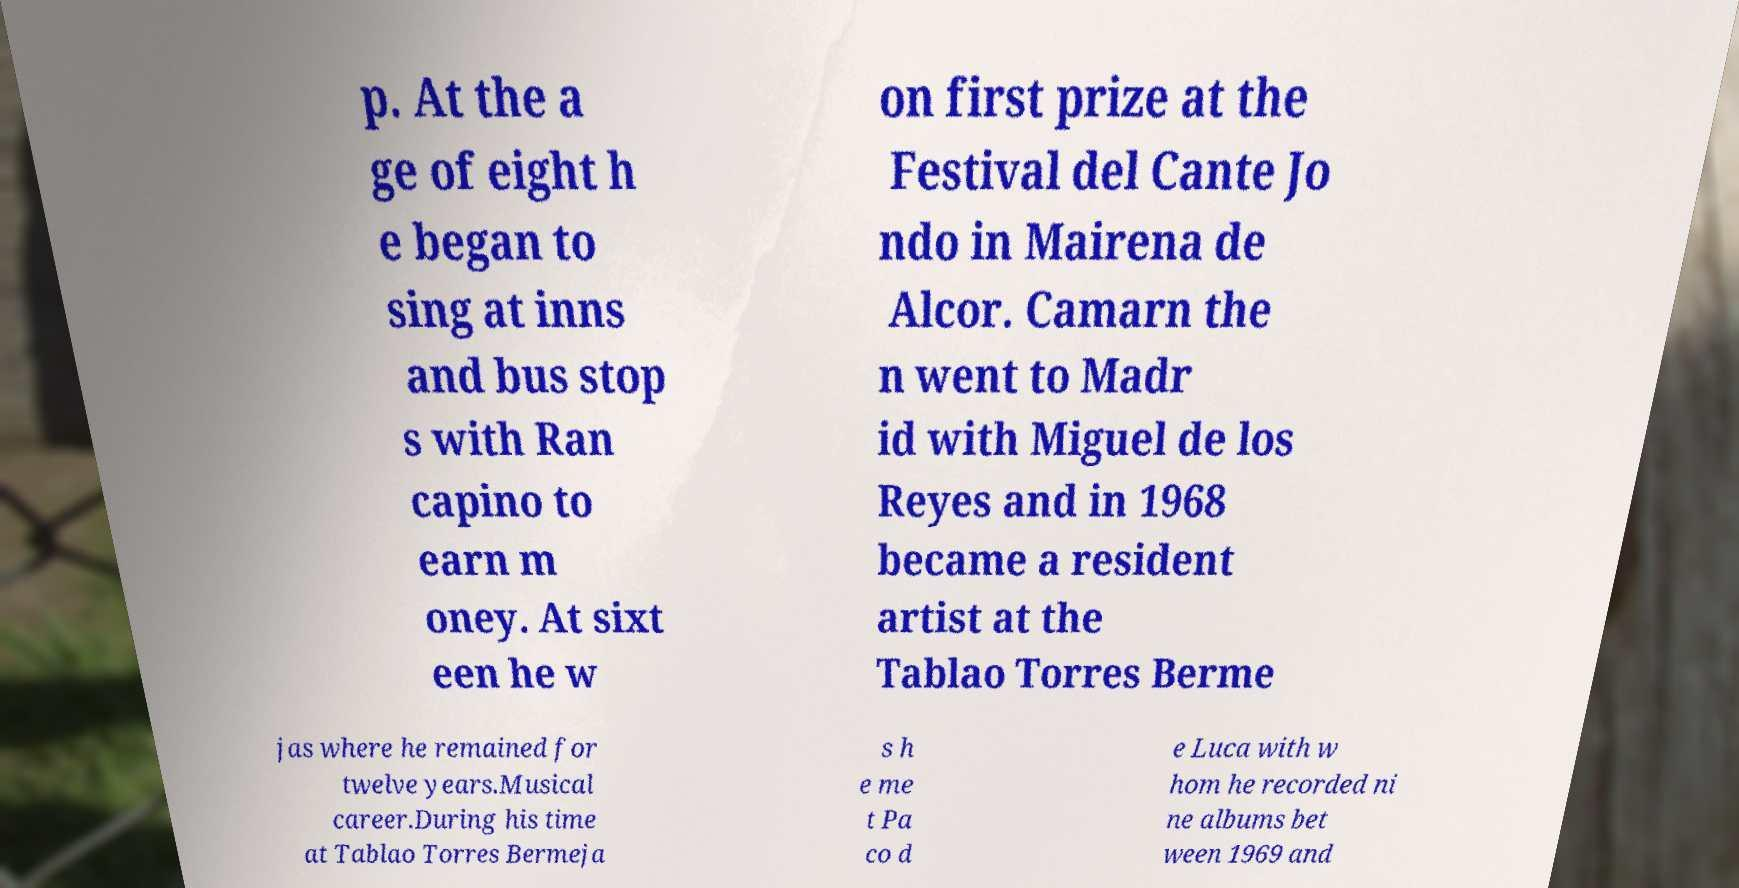Could you assist in decoding the text presented in this image and type it out clearly? p. At the a ge of eight h e began to sing at inns and bus stop s with Ran capino to earn m oney. At sixt een he w on first prize at the Festival del Cante Jo ndo in Mairena de Alcor. Camarn the n went to Madr id with Miguel de los Reyes and in 1968 became a resident artist at the Tablao Torres Berme jas where he remained for twelve years.Musical career.During his time at Tablao Torres Bermeja s h e me t Pa co d e Luca with w hom he recorded ni ne albums bet ween 1969 and 